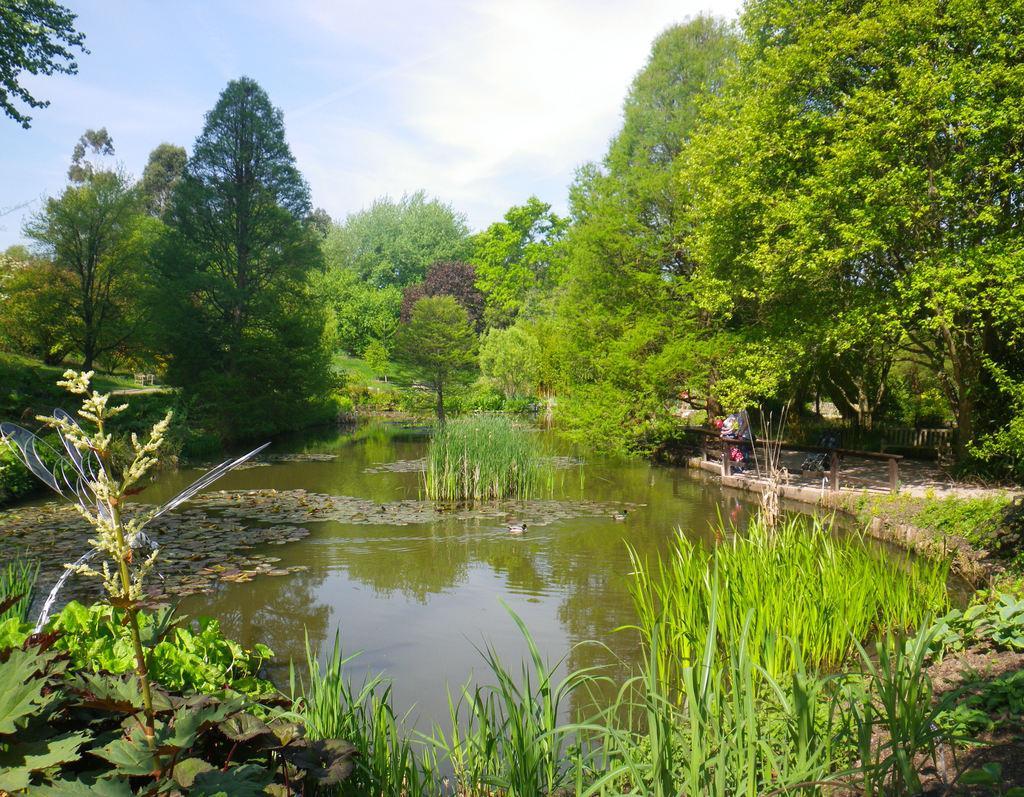How would you summarize this image in a sentence or two? In this picture we can see plants in water, trees and in the background we can see the sky with clouds. 